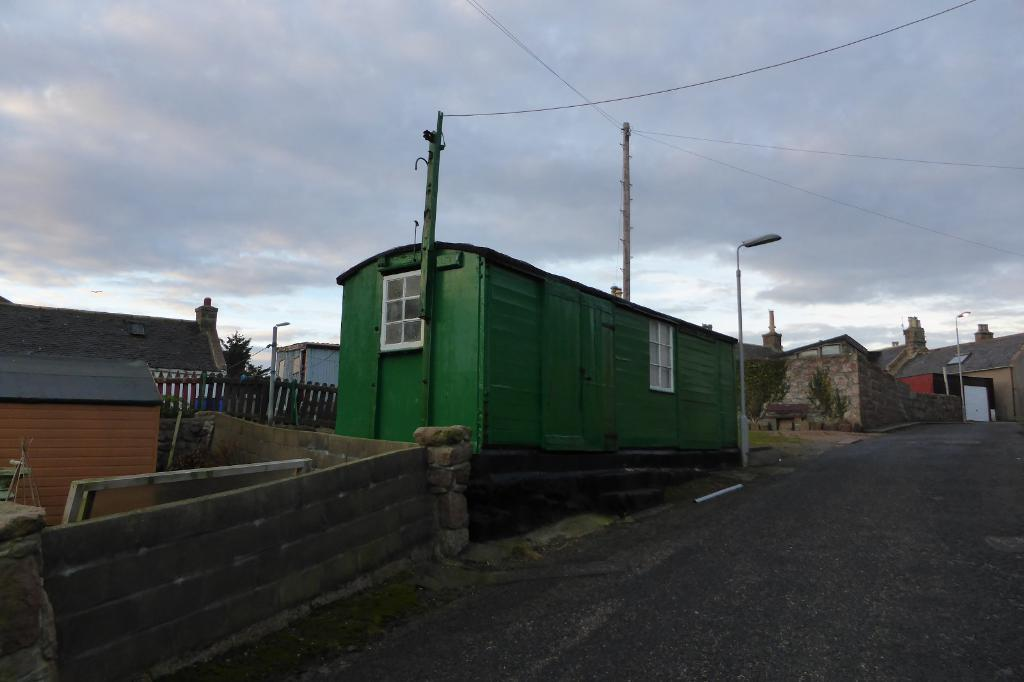What is located at the front of the image? There is a wall in the front of the image. What can be seen in the center of the image? There are houses and poles in the center of the image. What is visible in the background of the image? There are houses and a cloudy sky in the background of the image. How many frogs are hopping on the trail in the image? There is no trail or frogs present in the image. What emotion is being expressed by the houses in the image? The image does not depict emotions; it shows houses and other structures. 